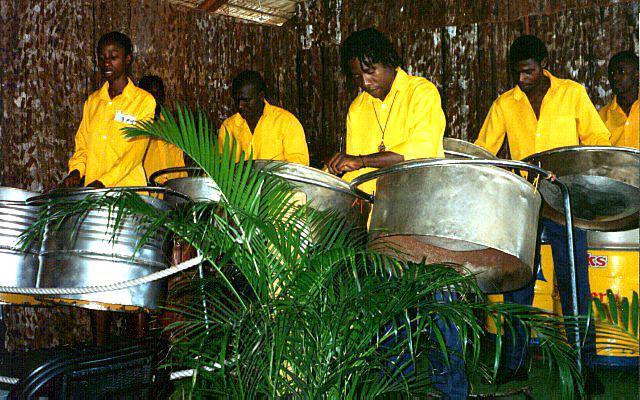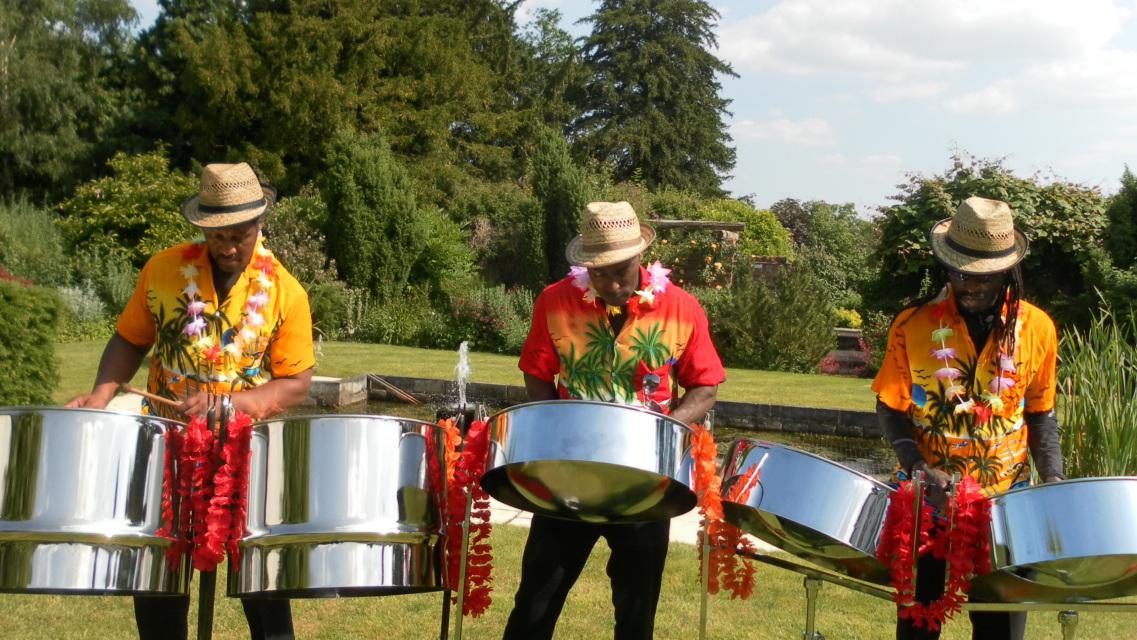The first image is the image on the left, the second image is the image on the right. Given the left and right images, does the statement "In one of the images, three people in straw hats are playing instruments." hold true? Answer yes or no. Yes. The first image is the image on the left, the second image is the image on the right. Assess this claim about the two images: "Exactly one of the bands is playing in sand.". Correct or not? Answer yes or no. No. 